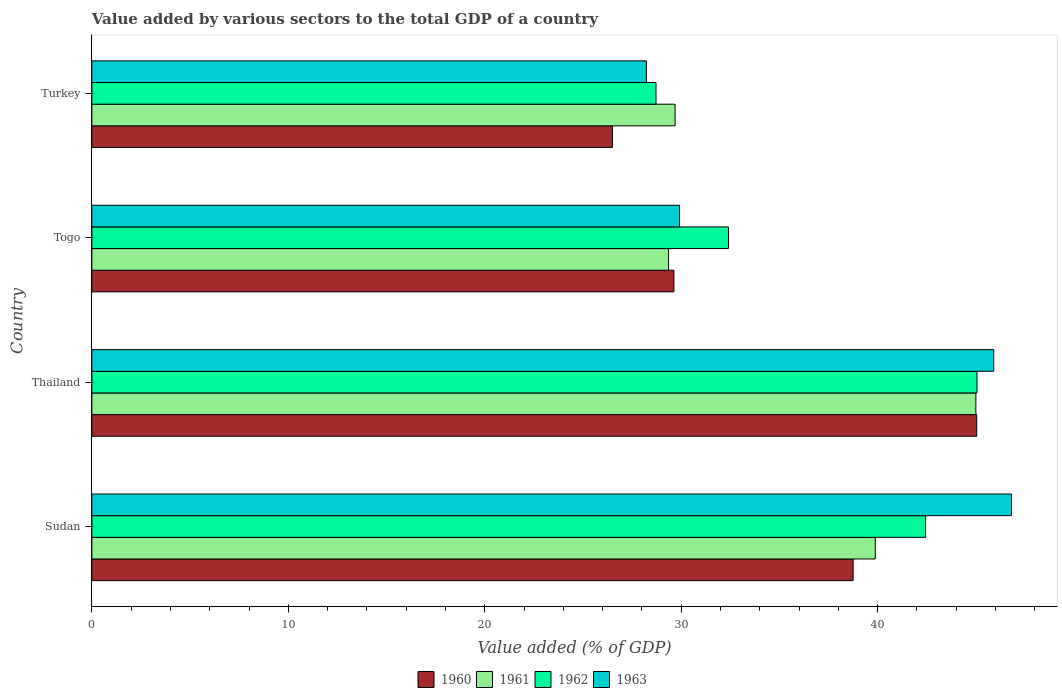Are the number of bars on each tick of the Y-axis equal?
Offer a terse response. Yes. How many bars are there on the 1st tick from the bottom?
Give a very brief answer. 4. What is the label of the 4th group of bars from the top?
Your answer should be compact. Sudan. In how many cases, is the number of bars for a given country not equal to the number of legend labels?
Offer a very short reply. 0. What is the value added by various sectors to the total GDP in 1962 in Turkey?
Your response must be concise. 28.72. Across all countries, what is the maximum value added by various sectors to the total GDP in 1962?
Make the answer very short. 45.05. Across all countries, what is the minimum value added by various sectors to the total GDP in 1961?
Keep it short and to the point. 29.35. In which country was the value added by various sectors to the total GDP in 1961 maximum?
Your response must be concise. Thailand. What is the total value added by various sectors to the total GDP in 1963 in the graph?
Provide a succinct answer. 150.86. What is the difference between the value added by various sectors to the total GDP in 1963 in Sudan and that in Turkey?
Give a very brief answer. 18.58. What is the difference between the value added by various sectors to the total GDP in 1961 in Togo and the value added by various sectors to the total GDP in 1963 in Turkey?
Your answer should be compact. 1.13. What is the average value added by various sectors to the total GDP in 1960 per country?
Keep it short and to the point. 34.98. What is the difference between the value added by various sectors to the total GDP in 1960 and value added by various sectors to the total GDP in 1963 in Thailand?
Your answer should be compact. -0.87. What is the ratio of the value added by various sectors to the total GDP in 1960 in Thailand to that in Turkey?
Provide a succinct answer. 1.7. Is the value added by various sectors to the total GDP in 1962 in Thailand less than that in Turkey?
Keep it short and to the point. No. What is the difference between the highest and the second highest value added by various sectors to the total GDP in 1962?
Give a very brief answer. 2.62. What is the difference between the highest and the lowest value added by various sectors to the total GDP in 1962?
Your answer should be very brief. 16.34. In how many countries, is the value added by various sectors to the total GDP in 1962 greater than the average value added by various sectors to the total GDP in 1962 taken over all countries?
Your response must be concise. 2. Is it the case that in every country, the sum of the value added by various sectors to the total GDP in 1961 and value added by various sectors to the total GDP in 1963 is greater than the sum of value added by various sectors to the total GDP in 1962 and value added by various sectors to the total GDP in 1960?
Your answer should be very brief. No. What does the 4th bar from the bottom in Togo represents?
Make the answer very short. 1963. Is it the case that in every country, the sum of the value added by various sectors to the total GDP in 1960 and value added by various sectors to the total GDP in 1963 is greater than the value added by various sectors to the total GDP in 1962?
Your answer should be compact. Yes. Are all the bars in the graph horizontal?
Make the answer very short. Yes. How many countries are there in the graph?
Your answer should be compact. 4. What is the difference between two consecutive major ticks on the X-axis?
Ensure brevity in your answer.  10. Does the graph contain grids?
Your answer should be compact. No. How many legend labels are there?
Offer a very short reply. 4. How are the legend labels stacked?
Ensure brevity in your answer.  Horizontal. What is the title of the graph?
Your answer should be very brief. Value added by various sectors to the total GDP of a country. Does "1999" appear as one of the legend labels in the graph?
Make the answer very short. No. What is the label or title of the X-axis?
Make the answer very short. Value added (% of GDP). What is the label or title of the Y-axis?
Give a very brief answer. Country. What is the Value added (% of GDP) in 1960 in Sudan?
Offer a terse response. 38.75. What is the Value added (% of GDP) of 1961 in Sudan?
Your response must be concise. 39.88. What is the Value added (% of GDP) in 1962 in Sudan?
Keep it short and to the point. 42.44. What is the Value added (% of GDP) of 1963 in Sudan?
Keep it short and to the point. 46.81. What is the Value added (% of GDP) in 1960 in Thailand?
Offer a very short reply. 45.04. What is the Value added (% of GDP) in 1961 in Thailand?
Keep it short and to the point. 45. What is the Value added (% of GDP) of 1962 in Thailand?
Your response must be concise. 45.05. What is the Value added (% of GDP) of 1963 in Thailand?
Your response must be concise. 45.91. What is the Value added (% of GDP) in 1960 in Togo?
Keep it short and to the point. 29.63. What is the Value added (% of GDP) in 1961 in Togo?
Give a very brief answer. 29.35. What is the Value added (% of GDP) of 1962 in Togo?
Make the answer very short. 32.41. What is the Value added (% of GDP) in 1963 in Togo?
Provide a succinct answer. 29.91. What is the Value added (% of GDP) in 1960 in Turkey?
Make the answer very short. 26.5. What is the Value added (% of GDP) in 1961 in Turkey?
Provide a succinct answer. 29.69. What is the Value added (% of GDP) of 1962 in Turkey?
Your answer should be very brief. 28.72. What is the Value added (% of GDP) of 1963 in Turkey?
Provide a succinct answer. 28.23. Across all countries, what is the maximum Value added (% of GDP) of 1960?
Provide a short and direct response. 45.04. Across all countries, what is the maximum Value added (% of GDP) of 1961?
Keep it short and to the point. 45. Across all countries, what is the maximum Value added (% of GDP) in 1962?
Keep it short and to the point. 45.05. Across all countries, what is the maximum Value added (% of GDP) of 1963?
Offer a very short reply. 46.81. Across all countries, what is the minimum Value added (% of GDP) in 1960?
Make the answer very short. 26.5. Across all countries, what is the minimum Value added (% of GDP) of 1961?
Your answer should be very brief. 29.35. Across all countries, what is the minimum Value added (% of GDP) in 1962?
Provide a short and direct response. 28.72. Across all countries, what is the minimum Value added (% of GDP) in 1963?
Keep it short and to the point. 28.23. What is the total Value added (% of GDP) of 1960 in the graph?
Offer a very short reply. 139.91. What is the total Value added (% of GDP) of 1961 in the graph?
Your response must be concise. 143.92. What is the total Value added (% of GDP) of 1962 in the graph?
Give a very brief answer. 148.62. What is the total Value added (% of GDP) in 1963 in the graph?
Provide a succinct answer. 150.86. What is the difference between the Value added (% of GDP) of 1960 in Sudan and that in Thailand?
Offer a very short reply. -6.29. What is the difference between the Value added (% of GDP) of 1961 in Sudan and that in Thailand?
Your answer should be very brief. -5.12. What is the difference between the Value added (% of GDP) in 1962 in Sudan and that in Thailand?
Ensure brevity in your answer.  -2.62. What is the difference between the Value added (% of GDP) of 1963 in Sudan and that in Thailand?
Offer a very short reply. 0.9. What is the difference between the Value added (% of GDP) of 1960 in Sudan and that in Togo?
Provide a short and direct response. 9.12. What is the difference between the Value added (% of GDP) of 1961 in Sudan and that in Togo?
Ensure brevity in your answer.  10.52. What is the difference between the Value added (% of GDP) in 1962 in Sudan and that in Togo?
Your answer should be compact. 10.03. What is the difference between the Value added (% of GDP) in 1963 in Sudan and that in Togo?
Give a very brief answer. 16.9. What is the difference between the Value added (% of GDP) of 1960 in Sudan and that in Turkey?
Provide a succinct answer. 12.25. What is the difference between the Value added (% of GDP) of 1961 in Sudan and that in Turkey?
Your response must be concise. 10.19. What is the difference between the Value added (% of GDP) of 1962 in Sudan and that in Turkey?
Keep it short and to the point. 13.72. What is the difference between the Value added (% of GDP) in 1963 in Sudan and that in Turkey?
Offer a terse response. 18.58. What is the difference between the Value added (% of GDP) of 1960 in Thailand and that in Togo?
Give a very brief answer. 15.41. What is the difference between the Value added (% of GDP) in 1961 in Thailand and that in Togo?
Provide a short and direct response. 15.64. What is the difference between the Value added (% of GDP) of 1962 in Thailand and that in Togo?
Make the answer very short. 12.65. What is the difference between the Value added (% of GDP) in 1963 in Thailand and that in Togo?
Give a very brief answer. 15.99. What is the difference between the Value added (% of GDP) in 1960 in Thailand and that in Turkey?
Your answer should be very brief. 18.54. What is the difference between the Value added (% of GDP) in 1961 in Thailand and that in Turkey?
Offer a very short reply. 15.31. What is the difference between the Value added (% of GDP) of 1962 in Thailand and that in Turkey?
Offer a terse response. 16.34. What is the difference between the Value added (% of GDP) in 1963 in Thailand and that in Turkey?
Your answer should be compact. 17.68. What is the difference between the Value added (% of GDP) in 1960 in Togo and that in Turkey?
Offer a terse response. 3.13. What is the difference between the Value added (% of GDP) in 1961 in Togo and that in Turkey?
Your answer should be compact. -0.33. What is the difference between the Value added (% of GDP) of 1962 in Togo and that in Turkey?
Your response must be concise. 3.69. What is the difference between the Value added (% of GDP) in 1963 in Togo and that in Turkey?
Give a very brief answer. 1.69. What is the difference between the Value added (% of GDP) of 1960 in Sudan and the Value added (% of GDP) of 1961 in Thailand?
Keep it short and to the point. -6.25. What is the difference between the Value added (% of GDP) in 1960 in Sudan and the Value added (% of GDP) in 1962 in Thailand?
Ensure brevity in your answer.  -6.31. What is the difference between the Value added (% of GDP) in 1960 in Sudan and the Value added (% of GDP) in 1963 in Thailand?
Your answer should be compact. -7.16. What is the difference between the Value added (% of GDP) of 1961 in Sudan and the Value added (% of GDP) of 1962 in Thailand?
Offer a very short reply. -5.18. What is the difference between the Value added (% of GDP) in 1961 in Sudan and the Value added (% of GDP) in 1963 in Thailand?
Give a very brief answer. -6.03. What is the difference between the Value added (% of GDP) in 1962 in Sudan and the Value added (% of GDP) in 1963 in Thailand?
Provide a short and direct response. -3.47. What is the difference between the Value added (% of GDP) of 1960 in Sudan and the Value added (% of GDP) of 1961 in Togo?
Offer a terse response. 9.39. What is the difference between the Value added (% of GDP) of 1960 in Sudan and the Value added (% of GDP) of 1962 in Togo?
Your response must be concise. 6.34. What is the difference between the Value added (% of GDP) in 1960 in Sudan and the Value added (% of GDP) in 1963 in Togo?
Your answer should be compact. 8.83. What is the difference between the Value added (% of GDP) in 1961 in Sudan and the Value added (% of GDP) in 1962 in Togo?
Your response must be concise. 7.47. What is the difference between the Value added (% of GDP) in 1961 in Sudan and the Value added (% of GDP) in 1963 in Togo?
Give a very brief answer. 9.96. What is the difference between the Value added (% of GDP) of 1962 in Sudan and the Value added (% of GDP) of 1963 in Togo?
Your answer should be very brief. 12.52. What is the difference between the Value added (% of GDP) of 1960 in Sudan and the Value added (% of GDP) of 1961 in Turkey?
Keep it short and to the point. 9.06. What is the difference between the Value added (% of GDP) of 1960 in Sudan and the Value added (% of GDP) of 1962 in Turkey?
Ensure brevity in your answer.  10.03. What is the difference between the Value added (% of GDP) in 1960 in Sudan and the Value added (% of GDP) in 1963 in Turkey?
Keep it short and to the point. 10.52. What is the difference between the Value added (% of GDP) in 1961 in Sudan and the Value added (% of GDP) in 1962 in Turkey?
Your response must be concise. 11.16. What is the difference between the Value added (% of GDP) of 1961 in Sudan and the Value added (% of GDP) of 1963 in Turkey?
Ensure brevity in your answer.  11.65. What is the difference between the Value added (% of GDP) in 1962 in Sudan and the Value added (% of GDP) in 1963 in Turkey?
Offer a very short reply. 14.21. What is the difference between the Value added (% of GDP) of 1960 in Thailand and the Value added (% of GDP) of 1961 in Togo?
Make the answer very short. 15.68. What is the difference between the Value added (% of GDP) in 1960 in Thailand and the Value added (% of GDP) in 1962 in Togo?
Give a very brief answer. 12.63. What is the difference between the Value added (% of GDP) in 1960 in Thailand and the Value added (% of GDP) in 1963 in Togo?
Keep it short and to the point. 15.12. What is the difference between the Value added (% of GDP) in 1961 in Thailand and the Value added (% of GDP) in 1962 in Togo?
Your response must be concise. 12.59. What is the difference between the Value added (% of GDP) of 1961 in Thailand and the Value added (% of GDP) of 1963 in Togo?
Your answer should be compact. 15.08. What is the difference between the Value added (% of GDP) in 1962 in Thailand and the Value added (% of GDP) in 1963 in Togo?
Your answer should be compact. 15.14. What is the difference between the Value added (% of GDP) of 1960 in Thailand and the Value added (% of GDP) of 1961 in Turkey?
Ensure brevity in your answer.  15.35. What is the difference between the Value added (% of GDP) of 1960 in Thailand and the Value added (% of GDP) of 1962 in Turkey?
Make the answer very short. 16.32. What is the difference between the Value added (% of GDP) in 1960 in Thailand and the Value added (% of GDP) in 1963 in Turkey?
Provide a short and direct response. 16.81. What is the difference between the Value added (% of GDP) of 1961 in Thailand and the Value added (% of GDP) of 1962 in Turkey?
Ensure brevity in your answer.  16.28. What is the difference between the Value added (% of GDP) in 1961 in Thailand and the Value added (% of GDP) in 1963 in Turkey?
Make the answer very short. 16.77. What is the difference between the Value added (% of GDP) of 1962 in Thailand and the Value added (% of GDP) of 1963 in Turkey?
Offer a terse response. 16.83. What is the difference between the Value added (% of GDP) of 1960 in Togo and the Value added (% of GDP) of 1961 in Turkey?
Your answer should be very brief. -0.06. What is the difference between the Value added (% of GDP) in 1960 in Togo and the Value added (% of GDP) in 1962 in Turkey?
Your answer should be very brief. 0.91. What is the difference between the Value added (% of GDP) of 1960 in Togo and the Value added (% of GDP) of 1963 in Turkey?
Offer a very short reply. 1.4. What is the difference between the Value added (% of GDP) of 1961 in Togo and the Value added (% of GDP) of 1962 in Turkey?
Offer a terse response. 0.64. What is the difference between the Value added (% of GDP) of 1961 in Togo and the Value added (% of GDP) of 1963 in Turkey?
Provide a short and direct response. 1.13. What is the difference between the Value added (% of GDP) in 1962 in Togo and the Value added (% of GDP) in 1963 in Turkey?
Offer a very short reply. 4.18. What is the average Value added (% of GDP) in 1960 per country?
Ensure brevity in your answer.  34.98. What is the average Value added (% of GDP) of 1961 per country?
Offer a very short reply. 35.98. What is the average Value added (% of GDP) of 1962 per country?
Provide a succinct answer. 37.15. What is the average Value added (% of GDP) in 1963 per country?
Give a very brief answer. 37.72. What is the difference between the Value added (% of GDP) of 1960 and Value added (% of GDP) of 1961 in Sudan?
Your answer should be compact. -1.13. What is the difference between the Value added (% of GDP) of 1960 and Value added (% of GDP) of 1962 in Sudan?
Your response must be concise. -3.69. What is the difference between the Value added (% of GDP) of 1960 and Value added (% of GDP) of 1963 in Sudan?
Ensure brevity in your answer.  -8.06. What is the difference between the Value added (% of GDP) of 1961 and Value added (% of GDP) of 1962 in Sudan?
Ensure brevity in your answer.  -2.56. What is the difference between the Value added (% of GDP) in 1961 and Value added (% of GDP) in 1963 in Sudan?
Keep it short and to the point. -6.93. What is the difference between the Value added (% of GDP) in 1962 and Value added (% of GDP) in 1963 in Sudan?
Provide a short and direct response. -4.37. What is the difference between the Value added (% of GDP) in 1960 and Value added (% of GDP) in 1961 in Thailand?
Your response must be concise. 0.04. What is the difference between the Value added (% of GDP) of 1960 and Value added (% of GDP) of 1962 in Thailand?
Offer a very short reply. -0.02. What is the difference between the Value added (% of GDP) of 1960 and Value added (% of GDP) of 1963 in Thailand?
Your answer should be compact. -0.87. What is the difference between the Value added (% of GDP) in 1961 and Value added (% of GDP) in 1962 in Thailand?
Ensure brevity in your answer.  -0.06. What is the difference between the Value added (% of GDP) in 1961 and Value added (% of GDP) in 1963 in Thailand?
Your answer should be very brief. -0.91. What is the difference between the Value added (% of GDP) in 1962 and Value added (% of GDP) in 1963 in Thailand?
Make the answer very short. -0.85. What is the difference between the Value added (% of GDP) of 1960 and Value added (% of GDP) of 1961 in Togo?
Make the answer very short. 0.27. What is the difference between the Value added (% of GDP) in 1960 and Value added (% of GDP) in 1962 in Togo?
Provide a succinct answer. -2.78. What is the difference between the Value added (% of GDP) of 1960 and Value added (% of GDP) of 1963 in Togo?
Your answer should be very brief. -0.28. What is the difference between the Value added (% of GDP) in 1961 and Value added (% of GDP) in 1962 in Togo?
Give a very brief answer. -3.05. What is the difference between the Value added (% of GDP) in 1961 and Value added (% of GDP) in 1963 in Togo?
Give a very brief answer. -0.56. What is the difference between the Value added (% of GDP) of 1962 and Value added (% of GDP) of 1963 in Togo?
Give a very brief answer. 2.49. What is the difference between the Value added (% of GDP) of 1960 and Value added (% of GDP) of 1961 in Turkey?
Offer a terse response. -3.19. What is the difference between the Value added (% of GDP) of 1960 and Value added (% of GDP) of 1962 in Turkey?
Offer a terse response. -2.22. What is the difference between the Value added (% of GDP) in 1960 and Value added (% of GDP) in 1963 in Turkey?
Give a very brief answer. -1.73. What is the difference between the Value added (% of GDP) in 1961 and Value added (% of GDP) in 1962 in Turkey?
Provide a short and direct response. 0.97. What is the difference between the Value added (% of GDP) of 1961 and Value added (% of GDP) of 1963 in Turkey?
Provide a succinct answer. 1.46. What is the difference between the Value added (% of GDP) in 1962 and Value added (% of GDP) in 1963 in Turkey?
Provide a succinct answer. 0.49. What is the ratio of the Value added (% of GDP) in 1960 in Sudan to that in Thailand?
Ensure brevity in your answer.  0.86. What is the ratio of the Value added (% of GDP) of 1961 in Sudan to that in Thailand?
Offer a terse response. 0.89. What is the ratio of the Value added (% of GDP) in 1962 in Sudan to that in Thailand?
Your answer should be very brief. 0.94. What is the ratio of the Value added (% of GDP) in 1963 in Sudan to that in Thailand?
Provide a short and direct response. 1.02. What is the ratio of the Value added (% of GDP) in 1960 in Sudan to that in Togo?
Give a very brief answer. 1.31. What is the ratio of the Value added (% of GDP) of 1961 in Sudan to that in Togo?
Offer a terse response. 1.36. What is the ratio of the Value added (% of GDP) in 1962 in Sudan to that in Togo?
Your answer should be very brief. 1.31. What is the ratio of the Value added (% of GDP) in 1963 in Sudan to that in Togo?
Provide a succinct answer. 1.56. What is the ratio of the Value added (% of GDP) of 1960 in Sudan to that in Turkey?
Your answer should be very brief. 1.46. What is the ratio of the Value added (% of GDP) of 1961 in Sudan to that in Turkey?
Keep it short and to the point. 1.34. What is the ratio of the Value added (% of GDP) of 1962 in Sudan to that in Turkey?
Ensure brevity in your answer.  1.48. What is the ratio of the Value added (% of GDP) of 1963 in Sudan to that in Turkey?
Keep it short and to the point. 1.66. What is the ratio of the Value added (% of GDP) in 1960 in Thailand to that in Togo?
Offer a very short reply. 1.52. What is the ratio of the Value added (% of GDP) in 1961 in Thailand to that in Togo?
Your answer should be compact. 1.53. What is the ratio of the Value added (% of GDP) in 1962 in Thailand to that in Togo?
Make the answer very short. 1.39. What is the ratio of the Value added (% of GDP) of 1963 in Thailand to that in Togo?
Offer a terse response. 1.53. What is the ratio of the Value added (% of GDP) of 1960 in Thailand to that in Turkey?
Provide a short and direct response. 1.7. What is the ratio of the Value added (% of GDP) of 1961 in Thailand to that in Turkey?
Provide a succinct answer. 1.52. What is the ratio of the Value added (% of GDP) in 1962 in Thailand to that in Turkey?
Your answer should be compact. 1.57. What is the ratio of the Value added (% of GDP) in 1963 in Thailand to that in Turkey?
Offer a terse response. 1.63. What is the ratio of the Value added (% of GDP) in 1960 in Togo to that in Turkey?
Your response must be concise. 1.12. What is the ratio of the Value added (% of GDP) in 1961 in Togo to that in Turkey?
Keep it short and to the point. 0.99. What is the ratio of the Value added (% of GDP) of 1962 in Togo to that in Turkey?
Offer a terse response. 1.13. What is the ratio of the Value added (% of GDP) in 1963 in Togo to that in Turkey?
Offer a very short reply. 1.06. What is the difference between the highest and the second highest Value added (% of GDP) in 1960?
Give a very brief answer. 6.29. What is the difference between the highest and the second highest Value added (% of GDP) in 1961?
Your answer should be compact. 5.12. What is the difference between the highest and the second highest Value added (% of GDP) of 1962?
Make the answer very short. 2.62. What is the difference between the highest and the second highest Value added (% of GDP) in 1963?
Provide a short and direct response. 0.9. What is the difference between the highest and the lowest Value added (% of GDP) in 1960?
Offer a very short reply. 18.54. What is the difference between the highest and the lowest Value added (% of GDP) of 1961?
Offer a terse response. 15.64. What is the difference between the highest and the lowest Value added (% of GDP) of 1962?
Provide a short and direct response. 16.34. What is the difference between the highest and the lowest Value added (% of GDP) of 1963?
Provide a succinct answer. 18.58. 